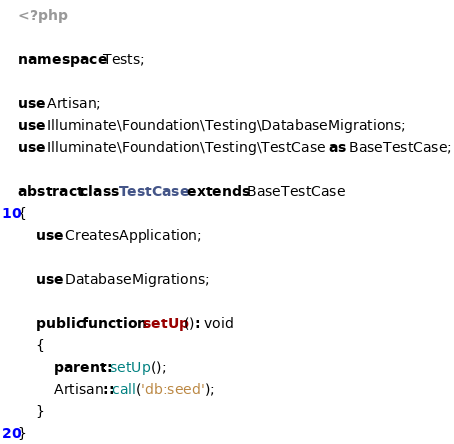Convert code to text. <code><loc_0><loc_0><loc_500><loc_500><_PHP_><?php

namespace Tests;

use Artisan;
use Illuminate\Foundation\Testing\DatabaseMigrations;
use Illuminate\Foundation\Testing\TestCase as BaseTestCase;

abstract class TestCase extends BaseTestCase
{
    use CreatesApplication;

    use DatabaseMigrations;

    public function setUp(): void
    {
        parent::setUp();
        Artisan::call('db:seed');
    }
}
</code> 